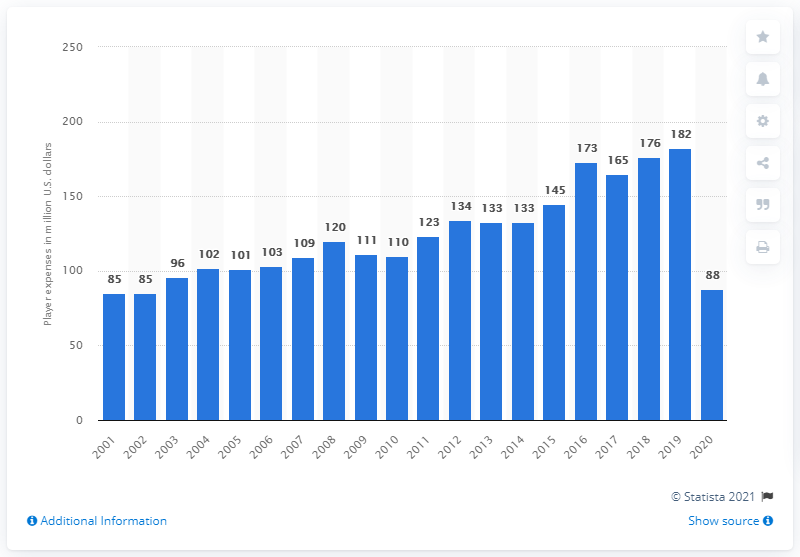Draw attention to some important aspects in this diagram. The payroll of the St. Louis Cardinals in 2020 was $88 million in dollars. 